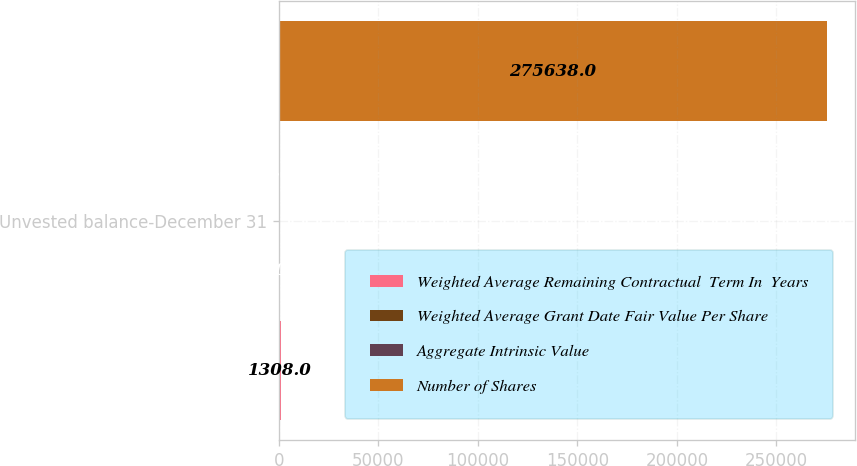Convert chart. <chart><loc_0><loc_0><loc_500><loc_500><stacked_bar_chart><ecel><fcel>Unvested balance-December 31<nl><fcel>Weighted Average Remaining Contractual  Term In  Years<fcel>1308<nl><fcel>Weighted Average Grant Date Fair Value Per Share<fcel>150.6<nl><fcel>Aggregate Intrinsic Value<fcel>1.5<nl><fcel>Number of Shares<fcel>275638<nl></chart> 